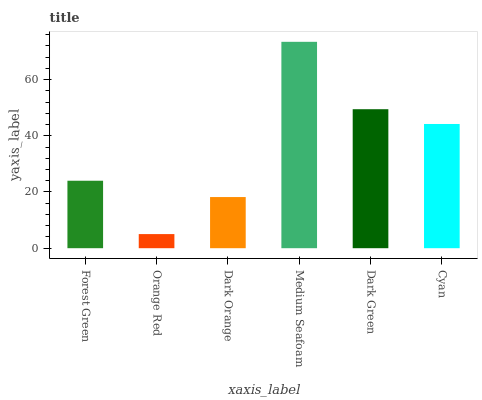Is Orange Red the minimum?
Answer yes or no. Yes. Is Medium Seafoam the maximum?
Answer yes or no. Yes. Is Dark Orange the minimum?
Answer yes or no. No. Is Dark Orange the maximum?
Answer yes or no. No. Is Dark Orange greater than Orange Red?
Answer yes or no. Yes. Is Orange Red less than Dark Orange?
Answer yes or no. Yes. Is Orange Red greater than Dark Orange?
Answer yes or no. No. Is Dark Orange less than Orange Red?
Answer yes or no. No. Is Cyan the high median?
Answer yes or no. Yes. Is Forest Green the low median?
Answer yes or no. Yes. Is Orange Red the high median?
Answer yes or no. No. Is Orange Red the low median?
Answer yes or no. No. 